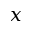<formula> <loc_0><loc_0><loc_500><loc_500>x</formula> 